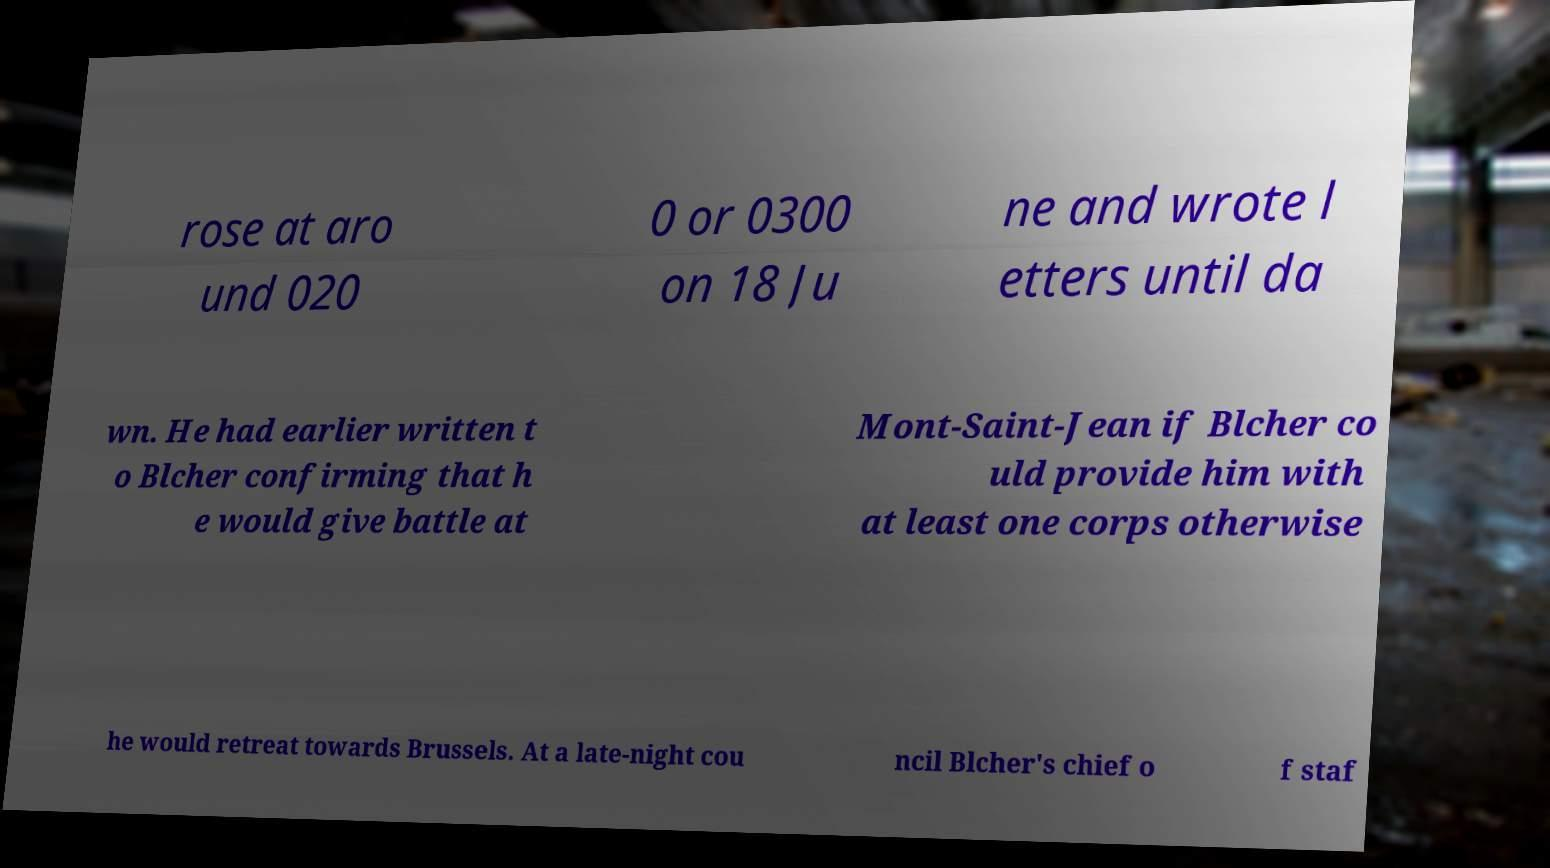Can you accurately transcribe the text from the provided image for me? rose at aro und 020 0 or 0300 on 18 Ju ne and wrote l etters until da wn. He had earlier written t o Blcher confirming that h e would give battle at Mont-Saint-Jean if Blcher co uld provide him with at least one corps otherwise he would retreat towards Brussels. At a late-night cou ncil Blcher's chief o f staf 